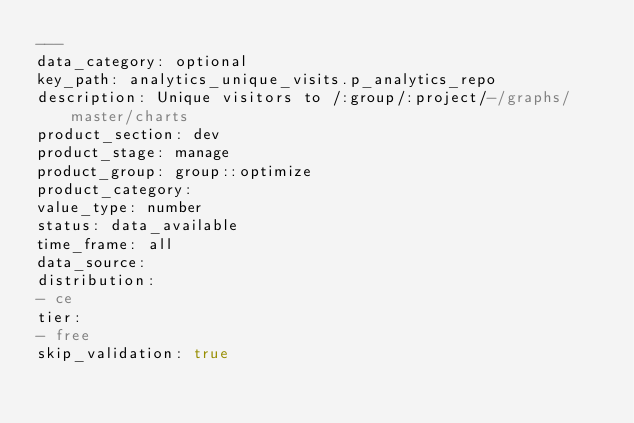Convert code to text. <code><loc_0><loc_0><loc_500><loc_500><_YAML_>---
data_category: optional
key_path: analytics_unique_visits.p_analytics_repo
description: Unique visitors to /:group/:project/-/graphs/master/charts
product_section: dev
product_stage: manage
product_group: group::optimize
product_category:
value_type: number
status: data_available
time_frame: all
data_source:
distribution:
- ce
tier:
- free
skip_validation: true
</code> 